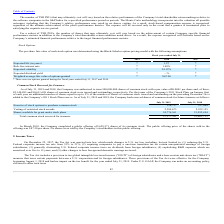According to Guidewire Software's financial document, How many shares was the company authorized to issue in 2019 and 2018? According to the financial document, 500,000,000. The relevant text states: "019 and 2018, the Company was authorized to issue 500,000,000 shares of common stock with a par value of $0.0001 per share and, of these,..." Also, What was the Exercise of stock options to purchase common stock in 2019 and 2018 respectively? The document shows two values: 216,727 and 537,064. From the document: "xercise of stock options to purchase common stock 216,727 537,064 of stock options to purchase common stock 216,727 537,064..." Also, What was the Vesting of restricted stock awards in 2019? According to the financial document, 2,384,673. The relevant text states: "Vesting of restricted stock awards 2,384,673 2,932,155..." Additionally, In which year was Exercise of stock options to purchase common stock less than 300,000? According to the financial document, 2019. The relevant text states: "July 31, 2019 July 31, 2018..." Also, can you calculate: What was the average Vesting of restricted stock awards for 2018 and 2019? To answer this question, I need to perform calculations using the financial data. The calculation is: (2,384,673 + 2,932,155) / 2, which equals 2658414. This is based on the information: "Vesting of restricted stock awards 2,384,673 2,932,155 Vesting of restricted stock awards 2,384,673 2,932,155..." The key data points involved are: 2,384,673, 2,932,155. Also, can you calculate: What is the change in the Shares available for grant under stock plans from 2018 to 2019? Based on the calculation: 24,776,361 - 21,592,494, the result is 3183867. This is based on the information: "Shares available for grant under stock plans 24,776,361 21,592,494 available for grant under stock plans 24,776,361 21,592,494..." The key data points involved are: 21,592,494, 24,776,361. 